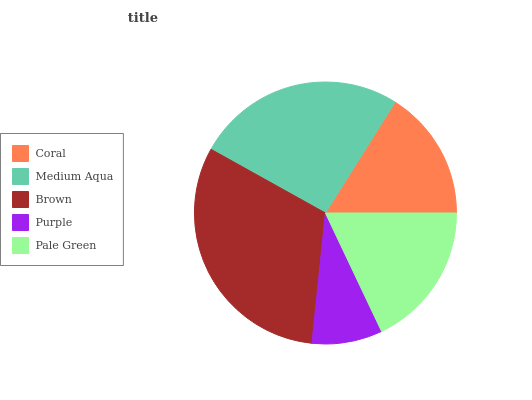Is Purple the minimum?
Answer yes or no. Yes. Is Brown the maximum?
Answer yes or no. Yes. Is Medium Aqua the minimum?
Answer yes or no. No. Is Medium Aqua the maximum?
Answer yes or no. No. Is Medium Aqua greater than Coral?
Answer yes or no. Yes. Is Coral less than Medium Aqua?
Answer yes or no. Yes. Is Coral greater than Medium Aqua?
Answer yes or no. No. Is Medium Aqua less than Coral?
Answer yes or no. No. Is Pale Green the high median?
Answer yes or no. Yes. Is Pale Green the low median?
Answer yes or no. Yes. Is Coral the high median?
Answer yes or no. No. Is Brown the low median?
Answer yes or no. No. 